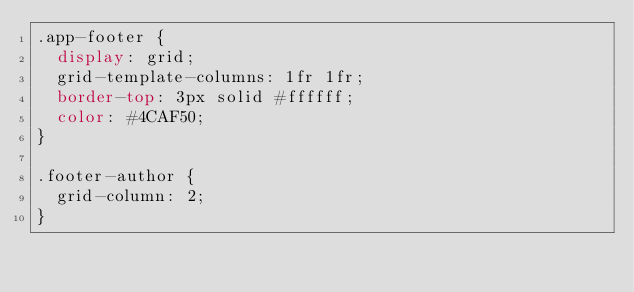<code> <loc_0><loc_0><loc_500><loc_500><_CSS_>.app-footer {
  display: grid;
  grid-template-columns: 1fr 1fr;
  border-top: 3px solid #ffffff;
  color: #4CAF50;
}

.footer-author {
  grid-column: 2;
}</code> 